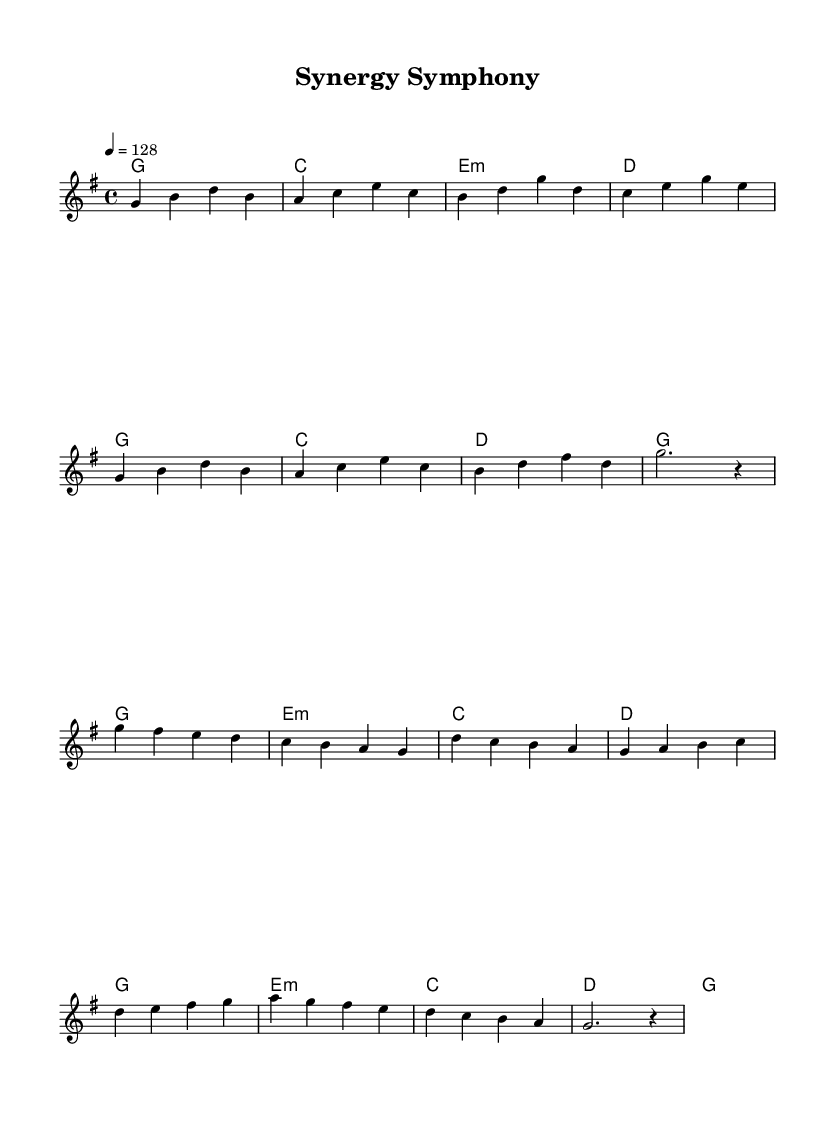What is the key signature of this music? The key signature is G major, which has one sharp (F#). This can be identified by looking at the key signature notation at the beginning of the piece.
Answer: G major What is the time signature of this music? The time signature is 4/4, indicated at the beginning of the piece. This means there are four beats in each measure, and the quarter note gets one beat.
Answer: 4/4 What is the tempo marking of this music? The tempo marking is quarter note equals 128, stated above the staff indicating how fast the music should be played.
Answer: 128 How many measures are in the verse section? By counting the measures in the melody portion labeled as the verse, we can see there are eight measures total before it transitions to the chorus.
Answer: 8 Which chord is repeated most frequently in the chorus? The chord G major appears regularly in the chorus section, supporting the melody that aligns with it. We can see it at the beginning and end of the chorus bars.
Answer: G What is the overall theme reflected in the title "Synergy Symphony"? The title suggests collaboration and harmony, which are common themes in K-Pop, emphasizing teamwork and unity in both music and message, as seen in the upbeat nature of the melody and collaboration-oriented lyrics.
Answer: Collaboration What type of song structure does this piece exhibit? This piece exhibits a verse-chorus structure, identifiable by the two distinct sections labeled verse and chorus, where each section has unique melodic and harmonic content.
Answer: Verse-Chorus 